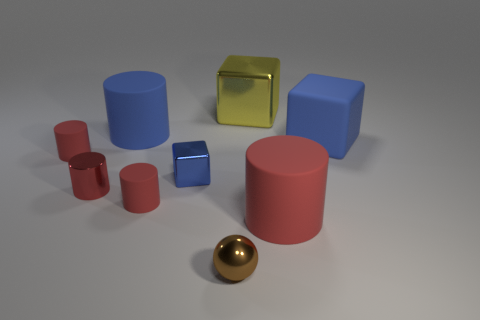There is a big rubber cylinder behind the big rubber cylinder on the right side of the tiny blue object; what is its color?
Your answer should be compact. Blue. What number of rubber objects are behind the small shiny cylinder and in front of the large blue rubber cylinder?
Offer a terse response. 2. Are there more red metal things than small rubber objects?
Offer a very short reply. No. What is the small sphere made of?
Offer a terse response. Metal. What number of yellow cubes are on the left side of the metal thing behind the tiny blue metallic thing?
Give a very brief answer. 0. Does the small metal cube have the same color as the big object that is on the left side of the tiny blue metal thing?
Provide a short and direct response. Yes. There is a rubber cube that is the same size as the blue cylinder; what color is it?
Your answer should be very brief. Blue. Is there a blue shiny thing of the same shape as the yellow metal object?
Offer a very short reply. Yes. Is the number of big red objects less than the number of small red matte cylinders?
Offer a very short reply. Yes. There is a large rubber object left of the tiny blue metal cube; what is its color?
Provide a succinct answer. Blue. 